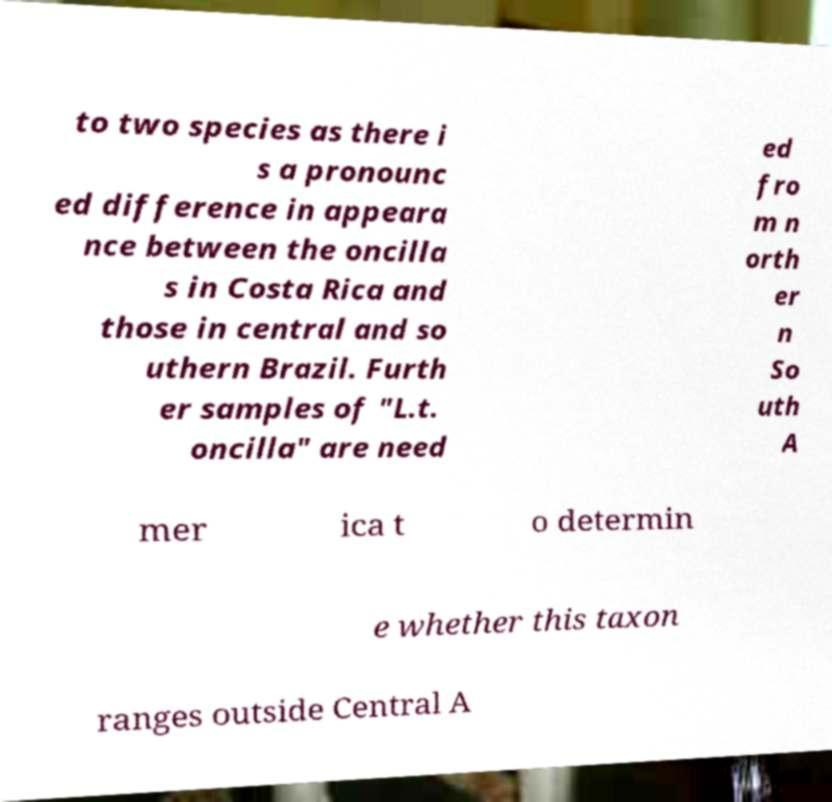Please identify and transcribe the text found in this image. to two species as there i s a pronounc ed difference in appeara nce between the oncilla s in Costa Rica and those in central and so uthern Brazil. Furth er samples of "L.t. oncilla" are need ed fro m n orth er n So uth A mer ica t o determin e whether this taxon ranges outside Central A 